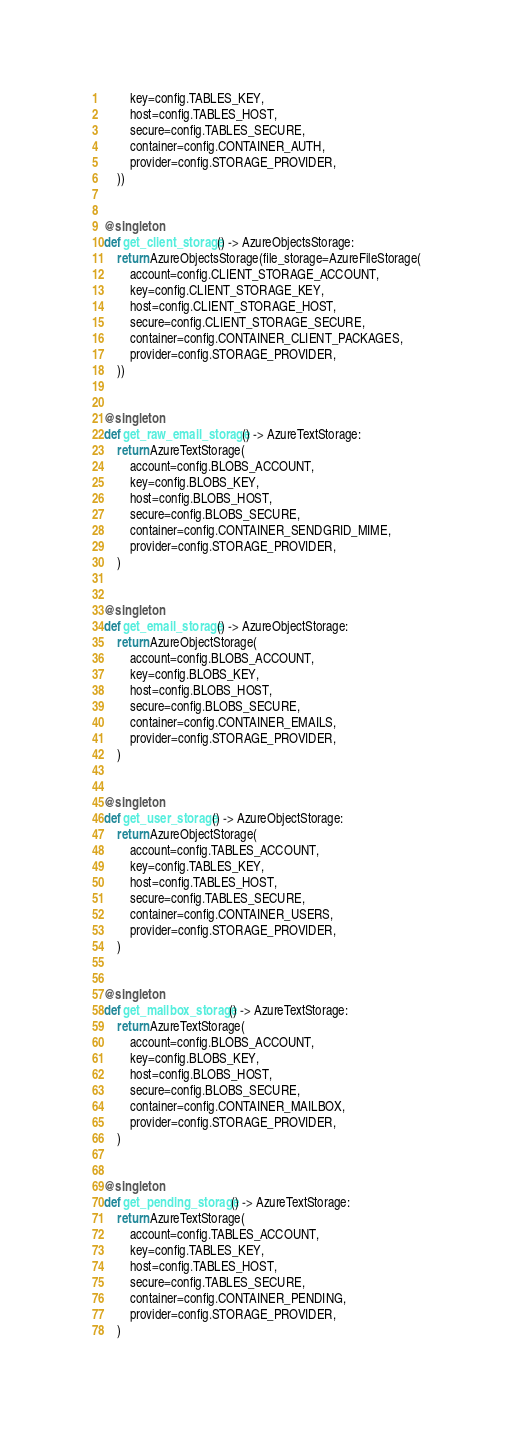<code> <loc_0><loc_0><loc_500><loc_500><_Python_>        key=config.TABLES_KEY,
        host=config.TABLES_HOST,
        secure=config.TABLES_SECURE,
        container=config.CONTAINER_AUTH,
        provider=config.STORAGE_PROVIDER,
    ))


@singleton
def get_client_storage() -> AzureObjectsStorage:
    return AzureObjectsStorage(file_storage=AzureFileStorage(
        account=config.CLIENT_STORAGE_ACCOUNT,
        key=config.CLIENT_STORAGE_KEY,
        host=config.CLIENT_STORAGE_HOST,
        secure=config.CLIENT_STORAGE_SECURE,
        container=config.CONTAINER_CLIENT_PACKAGES,
        provider=config.STORAGE_PROVIDER,
    ))


@singleton
def get_raw_email_storage() -> AzureTextStorage:
    return AzureTextStorage(
        account=config.BLOBS_ACCOUNT,
        key=config.BLOBS_KEY,
        host=config.BLOBS_HOST,
        secure=config.BLOBS_SECURE,
        container=config.CONTAINER_SENDGRID_MIME,
        provider=config.STORAGE_PROVIDER,
    )


@singleton
def get_email_storage() -> AzureObjectStorage:
    return AzureObjectStorage(
        account=config.BLOBS_ACCOUNT,
        key=config.BLOBS_KEY,
        host=config.BLOBS_HOST,
        secure=config.BLOBS_SECURE,
        container=config.CONTAINER_EMAILS,
        provider=config.STORAGE_PROVIDER,
    )


@singleton
def get_user_storage() -> AzureObjectStorage:
    return AzureObjectStorage(
        account=config.TABLES_ACCOUNT,
        key=config.TABLES_KEY,
        host=config.TABLES_HOST,
        secure=config.TABLES_SECURE,
        container=config.CONTAINER_USERS,
        provider=config.STORAGE_PROVIDER,
    )


@singleton
def get_mailbox_storage() -> AzureTextStorage:
    return AzureTextStorage(
        account=config.BLOBS_ACCOUNT,
        key=config.BLOBS_KEY,
        host=config.BLOBS_HOST,
        secure=config.BLOBS_SECURE,
        container=config.CONTAINER_MAILBOX,
        provider=config.STORAGE_PROVIDER,
    )


@singleton
def get_pending_storage() -> AzureTextStorage:
    return AzureTextStorage(
        account=config.TABLES_ACCOUNT,
        key=config.TABLES_KEY,
        host=config.TABLES_HOST,
        secure=config.TABLES_SECURE,
        container=config.CONTAINER_PENDING,
        provider=config.STORAGE_PROVIDER,
    )
</code> 